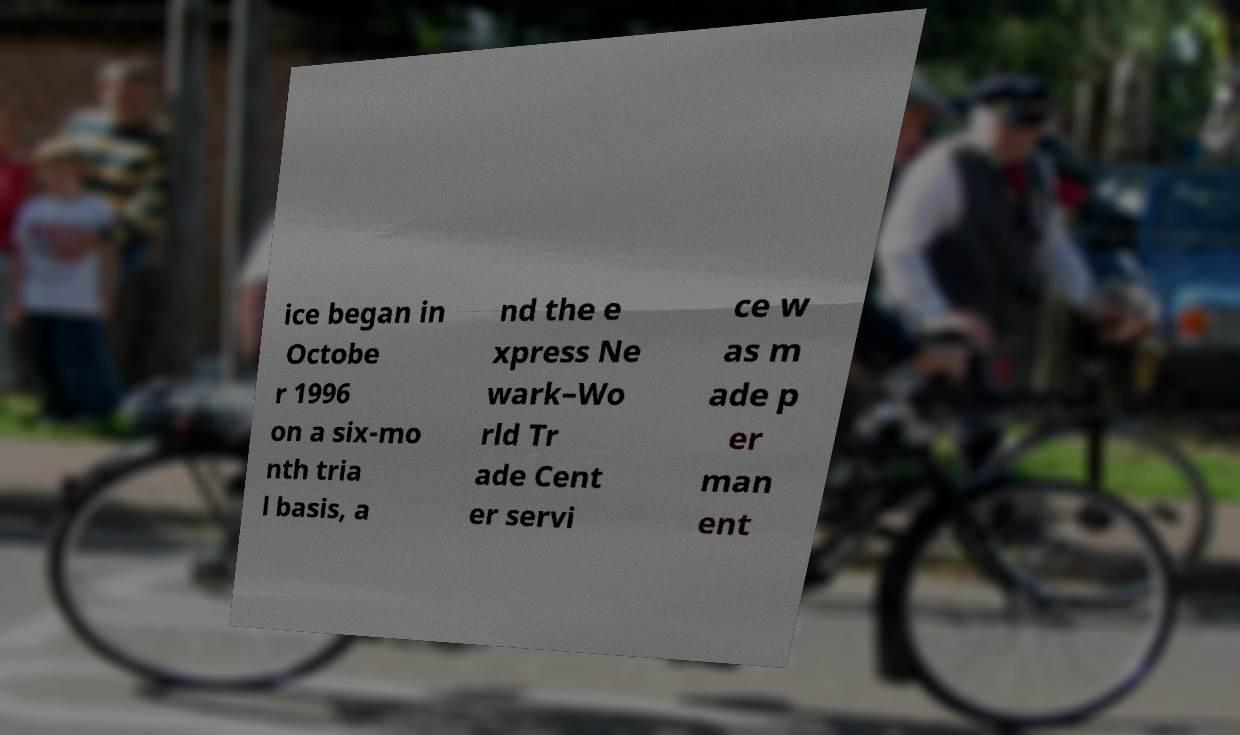Please identify and transcribe the text found in this image. ice began in Octobe r 1996 on a six-mo nth tria l basis, a nd the e xpress Ne wark–Wo rld Tr ade Cent er servi ce w as m ade p er man ent 